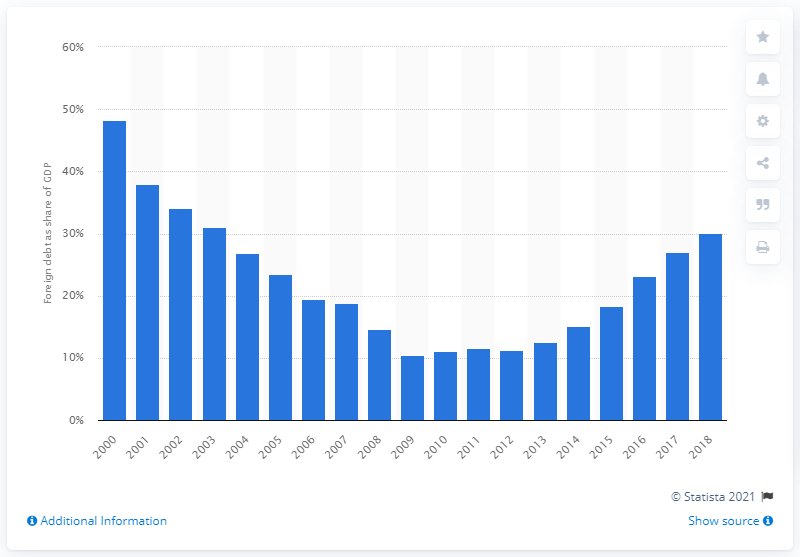Give some essential details in this illustration. In 2018, Ecuador's Gross Domestic Product (GDP) was heavily reliant on foreign creditors, with a significant portion, approximately 30.1%, owed to them. In 2019, Ecuador's lowest external debt was 10.4. 